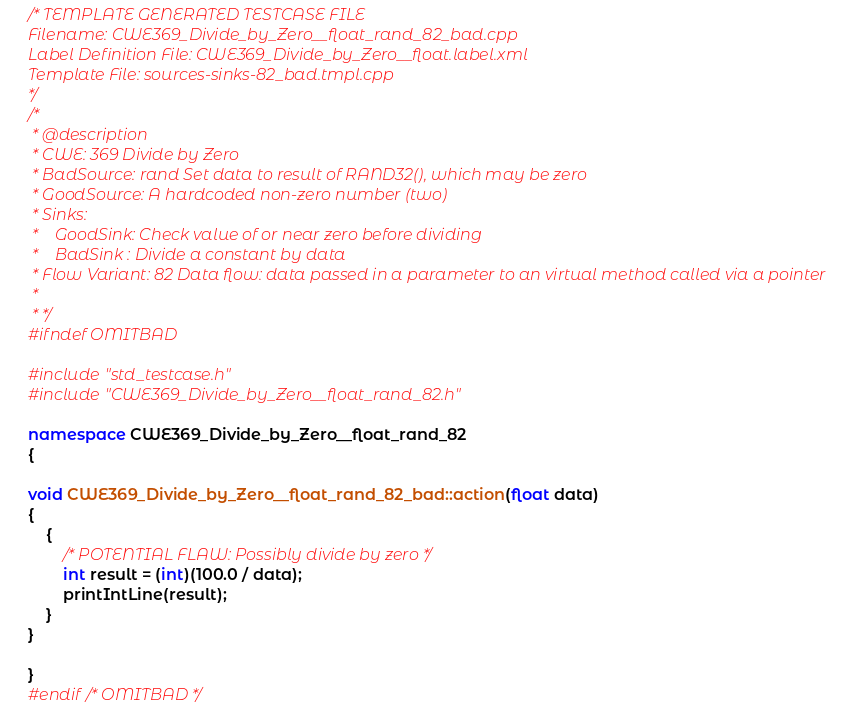<code> <loc_0><loc_0><loc_500><loc_500><_C++_>/* TEMPLATE GENERATED TESTCASE FILE
Filename: CWE369_Divide_by_Zero__float_rand_82_bad.cpp
Label Definition File: CWE369_Divide_by_Zero__float.label.xml
Template File: sources-sinks-82_bad.tmpl.cpp
*/
/*
 * @description
 * CWE: 369 Divide by Zero
 * BadSource: rand Set data to result of RAND32(), which may be zero
 * GoodSource: A hardcoded non-zero number (two)
 * Sinks:
 *    GoodSink: Check value of or near zero before dividing
 *    BadSink : Divide a constant by data
 * Flow Variant: 82 Data flow: data passed in a parameter to an virtual method called via a pointer
 *
 * */
#ifndef OMITBAD

#include "std_testcase.h"
#include "CWE369_Divide_by_Zero__float_rand_82.h"

namespace CWE369_Divide_by_Zero__float_rand_82
{

void CWE369_Divide_by_Zero__float_rand_82_bad::action(float data)
{
    {
        /* POTENTIAL FLAW: Possibly divide by zero */
        int result = (int)(100.0 / data);
        printIntLine(result);
    }
}

}
#endif /* OMITBAD */
</code> 